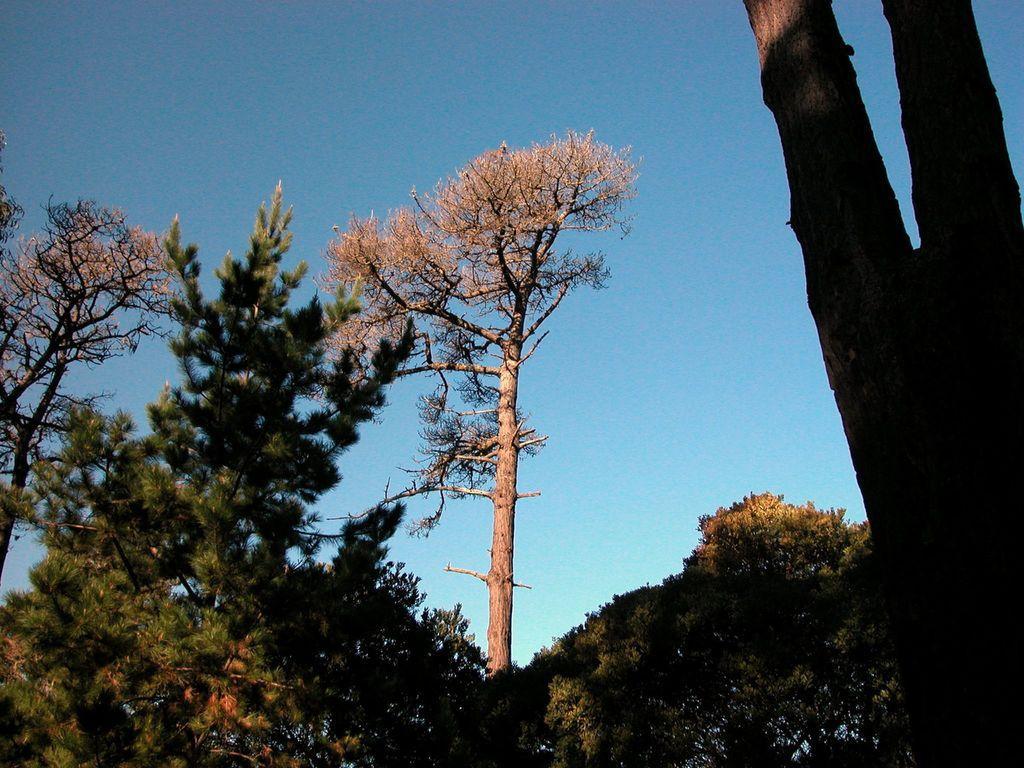Can you describe this image briefly? In this picture we can brown color dry tree in the middle of the image and around we can see some green trees. On the right corner of the image we can see huge tree trunk and above we can see clear blue sky. 